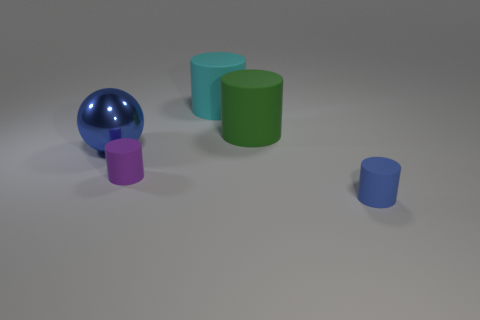Subtract all green cylinders. How many cylinders are left? 3 Subtract all cyan cylinders. How many cylinders are left? 3 Subtract all gray cylinders. Subtract all blue blocks. How many cylinders are left? 4 Add 3 purple cylinders. How many objects exist? 8 Subtract all spheres. How many objects are left? 4 Add 2 purple matte objects. How many purple matte objects are left? 3 Add 5 big green rubber objects. How many big green rubber objects exist? 6 Subtract 0 brown balls. How many objects are left? 5 Subtract all big cyan blocks. Subtract all small blue rubber objects. How many objects are left? 4 